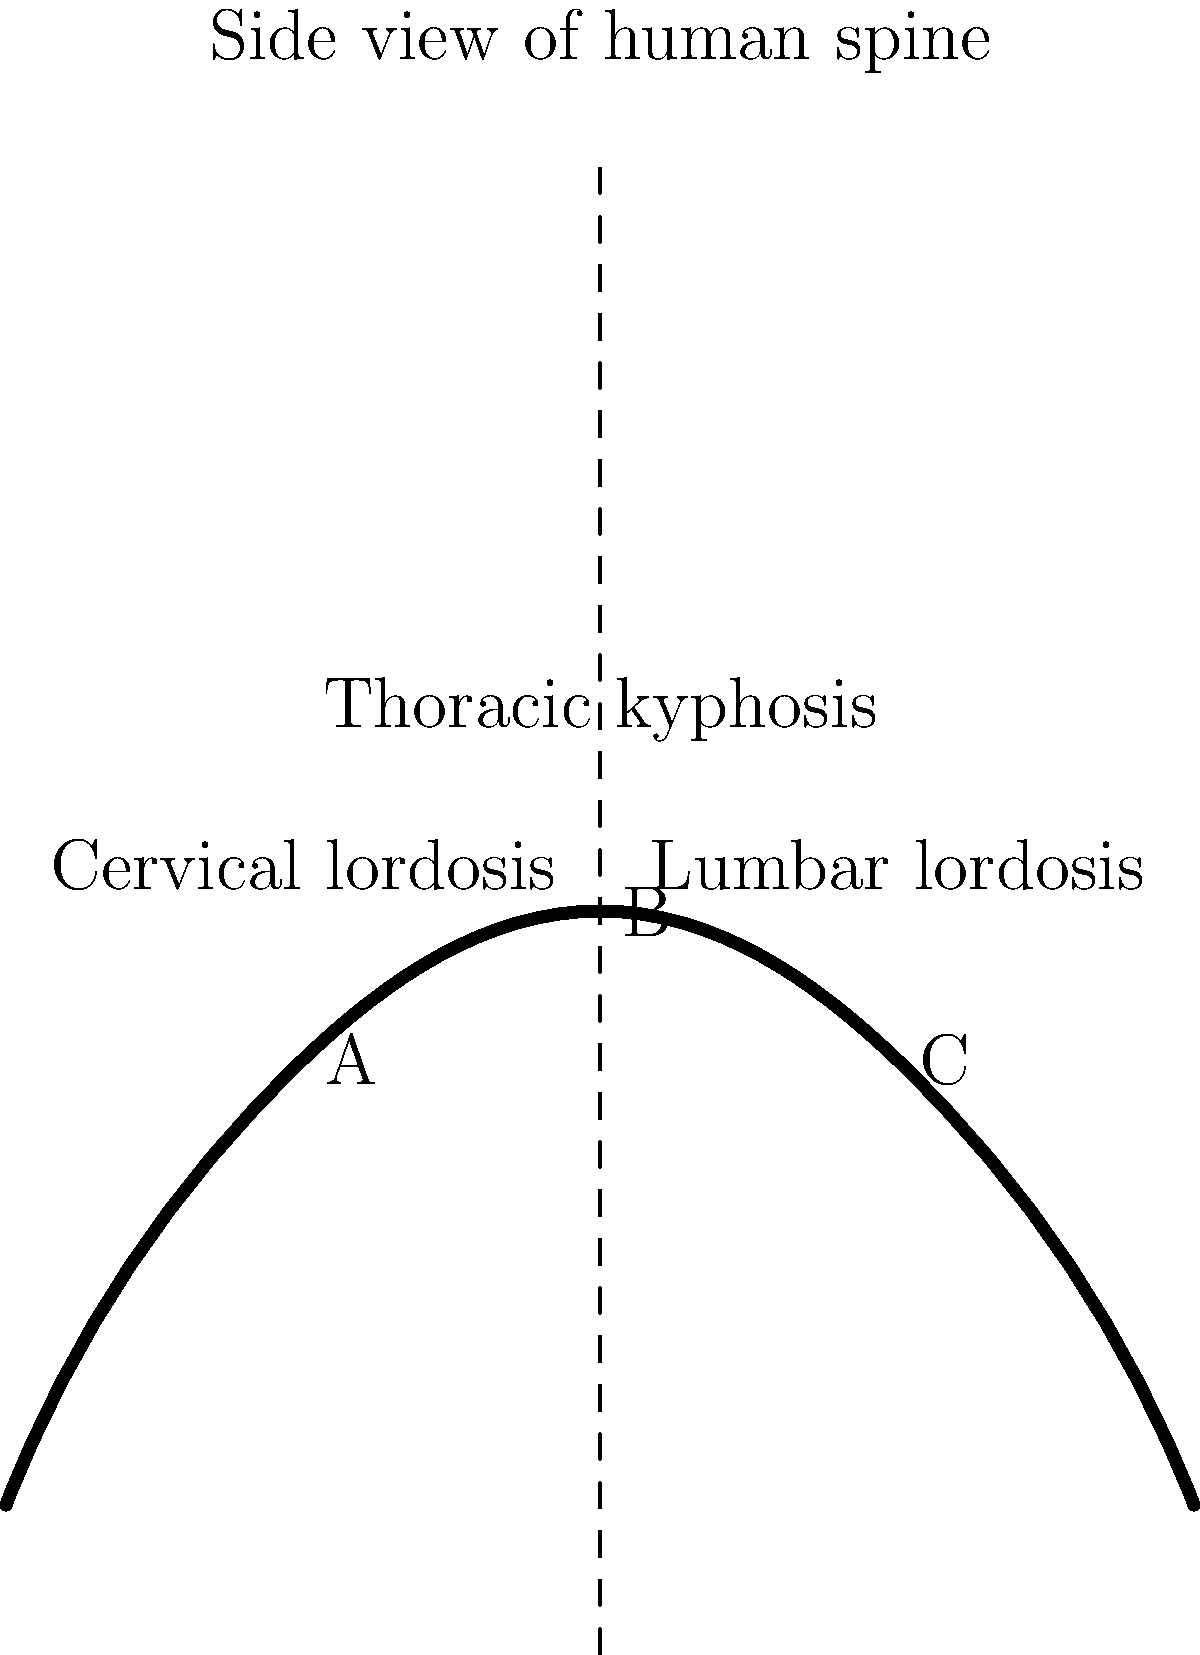In the side view of the human spine shown above, which region (A, B, or C) corresponds to thoracic kyphosis, and how does this curvature contribute to overall spinal function and posture? To answer this question, let's analyze the spinal curvature step-by-step:

1. The human spine has three natural curves when viewed from the side:
   a) Cervical lordosis (neck region)
   b) Thoracic kyphosis (upper back)
   c) Lumbar lordosis (lower back)

2. In the diagram:
   - Region A shows an inward curve at the top (cervical lordosis)
   - Region B shows an outward curve in the middle (thoracic kyphosis)
   - Region C shows an inward curve at the bottom (lumbar lordosis)

3. Therefore, region B corresponds to thoracic kyphosis.

4. Thoracic kyphosis contributes to spinal function and posture in several ways:
   a) It helps distribute the weight of the head and upper body more evenly.
   b) It increases the flexibility of the spine, allowing for a greater range of motion.
   c) It provides space for vital organs in the chest cavity, such as the heart and lungs.
   d) It acts as a shock absorber, reducing the impact of walking and other movements on the spine.

5. The normal thoracic kyphosis angle typically ranges from 20° to 45°. Excessive kyphosis (hyperkyphosis) or reduced kyphosis (hypokyphosis) can lead to postural problems and potential health issues.

6. The interaction between thoracic kyphosis and the other spinal curves (cervical and lumbar lordosis) creates an S-shape that is crucial for maintaining proper posture and balance.

7. This curvature also allows the spine to support more weight than a straight column could, making it more efficient in load-bearing and distributing forces along the vertebral column.
Answer: Region B; thoracic kyphosis provides flexibility, shock absorption, and proper weight distribution, contributing to overall spinal function and posture. 